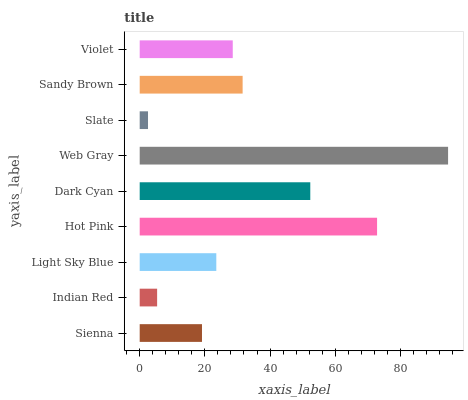Is Slate the minimum?
Answer yes or no. Yes. Is Web Gray the maximum?
Answer yes or no. Yes. Is Indian Red the minimum?
Answer yes or no. No. Is Indian Red the maximum?
Answer yes or no. No. Is Sienna greater than Indian Red?
Answer yes or no. Yes. Is Indian Red less than Sienna?
Answer yes or no. Yes. Is Indian Red greater than Sienna?
Answer yes or no. No. Is Sienna less than Indian Red?
Answer yes or no. No. Is Violet the high median?
Answer yes or no. Yes. Is Violet the low median?
Answer yes or no. Yes. Is Sienna the high median?
Answer yes or no. No. Is Indian Red the low median?
Answer yes or no. No. 